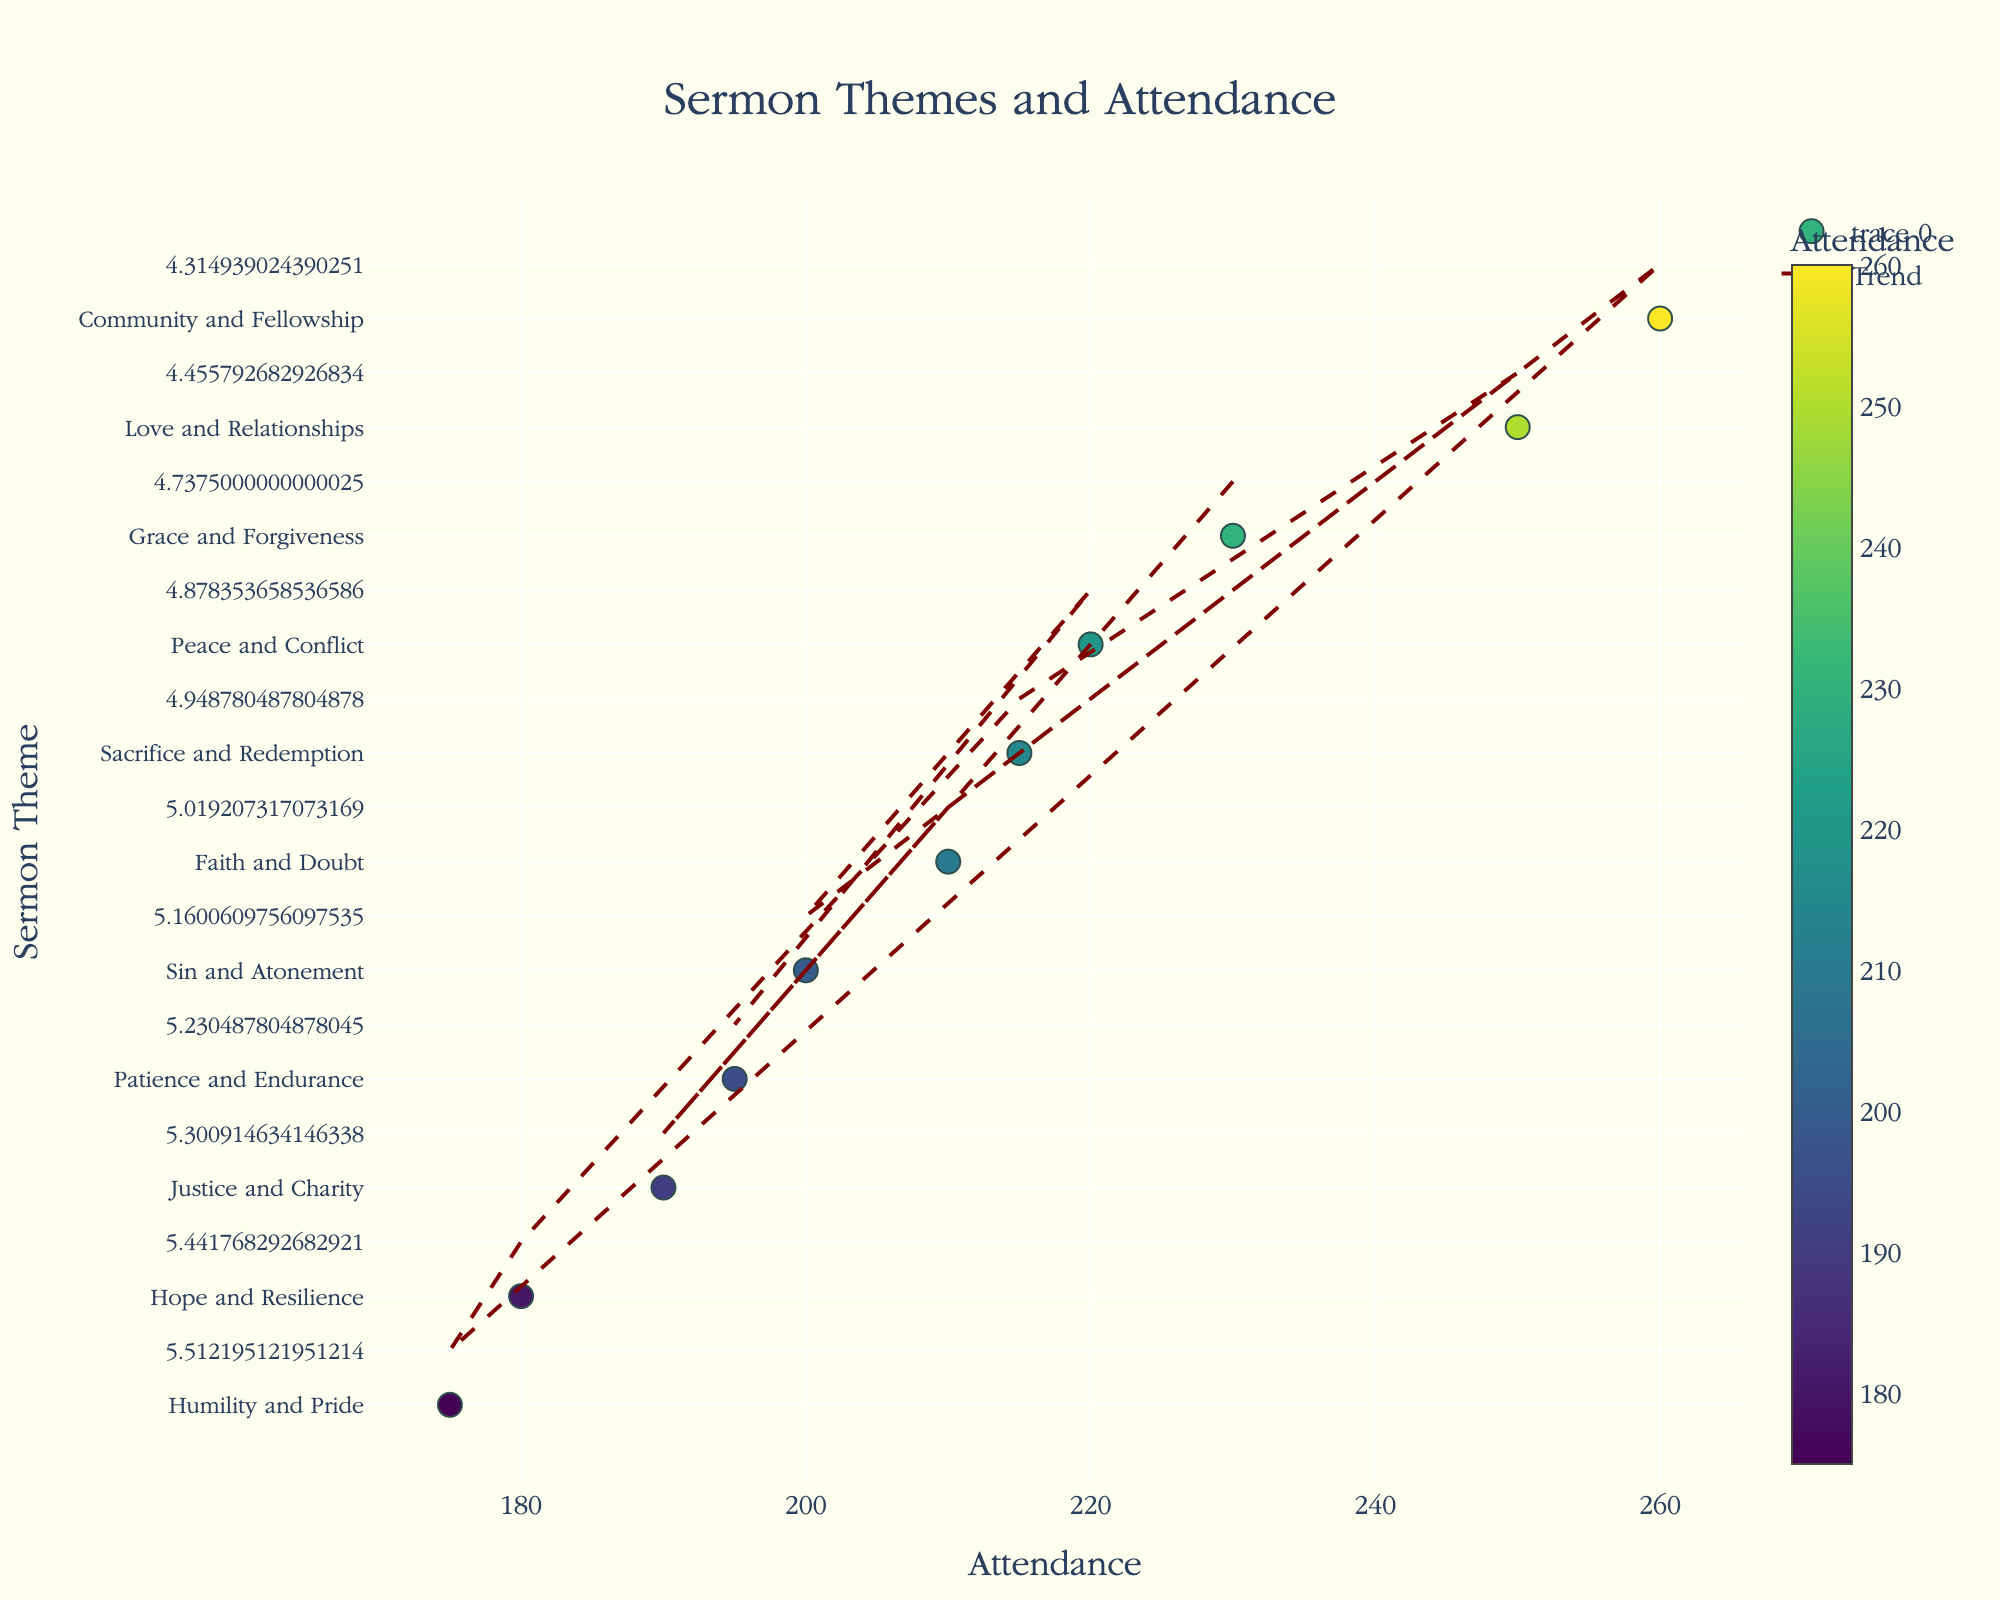What is the title of the figure? The title of the figure is displayed at the top, in a larger font and centered.
Answer: Sermon Themes and Attendance Which sermon theme had the highest attendance? The theme with the highest attendance will be represented by the point farthest to the right on the x-axis.
Answer: Community and Fellowship What is the general trend indicated by the trend line? The trend line shows the general direction of the data points from left to right, representing the overall trend in attendance rates.
Answer: Increasing How many sermon themes had an attendance rate of 200 or more? Count the number of points to the right of or at the 200 mark on the x-axis.
Answer: 7 Which sermon themes showed the lowest attendance rates? The themes closest to the left edge of the x-axis indicate the lowest attendance rates.
Answer: Hope and Resilience and Humility and Pride Compare the attendance rates of "Grace and Forgiveness" and "Faith and Doubt". Find the corresponding x-values for these sermon themes and compare them.
Answer: Grace and Forgiveness (230) has higher attendance than Faith and Doubt (210) What is the difference in attendance between the highest and lowest attended sermon themes? Subtract the attendance figure of the lowest attended theme from the highest attended theme.
Answer: 260 - 175 = 85 Are there more sermon themes above or below the trend line? Visually count the number of data points above and below the trend line.
Answer: More above Which sermon themes are closest to the average attendance? Determine the average attendance and identify the themes with attendance rates near this value.
Answer: Attendance ranging around 210 could include Faith and Doubt and Sin and Atonement How does the attendance for "Patience and Endurance" compare to the overall trend? Compare the position of "Patience and Endurance" to the trend line to see if it falls above, below, or on the trend line.
Answer: Below the trend line 